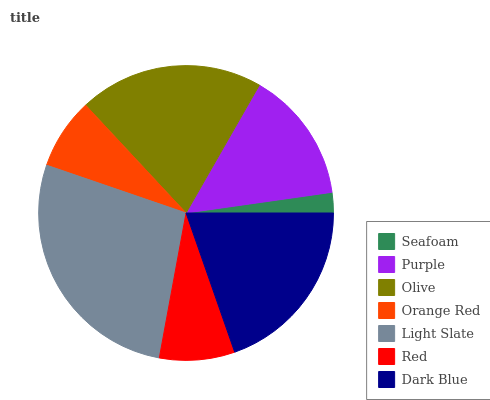Is Seafoam the minimum?
Answer yes or no. Yes. Is Light Slate the maximum?
Answer yes or no. Yes. Is Purple the minimum?
Answer yes or no. No. Is Purple the maximum?
Answer yes or no. No. Is Purple greater than Seafoam?
Answer yes or no. Yes. Is Seafoam less than Purple?
Answer yes or no. Yes. Is Seafoam greater than Purple?
Answer yes or no. No. Is Purple less than Seafoam?
Answer yes or no. No. Is Purple the high median?
Answer yes or no. Yes. Is Purple the low median?
Answer yes or no. Yes. Is Red the high median?
Answer yes or no. No. Is Red the low median?
Answer yes or no. No. 